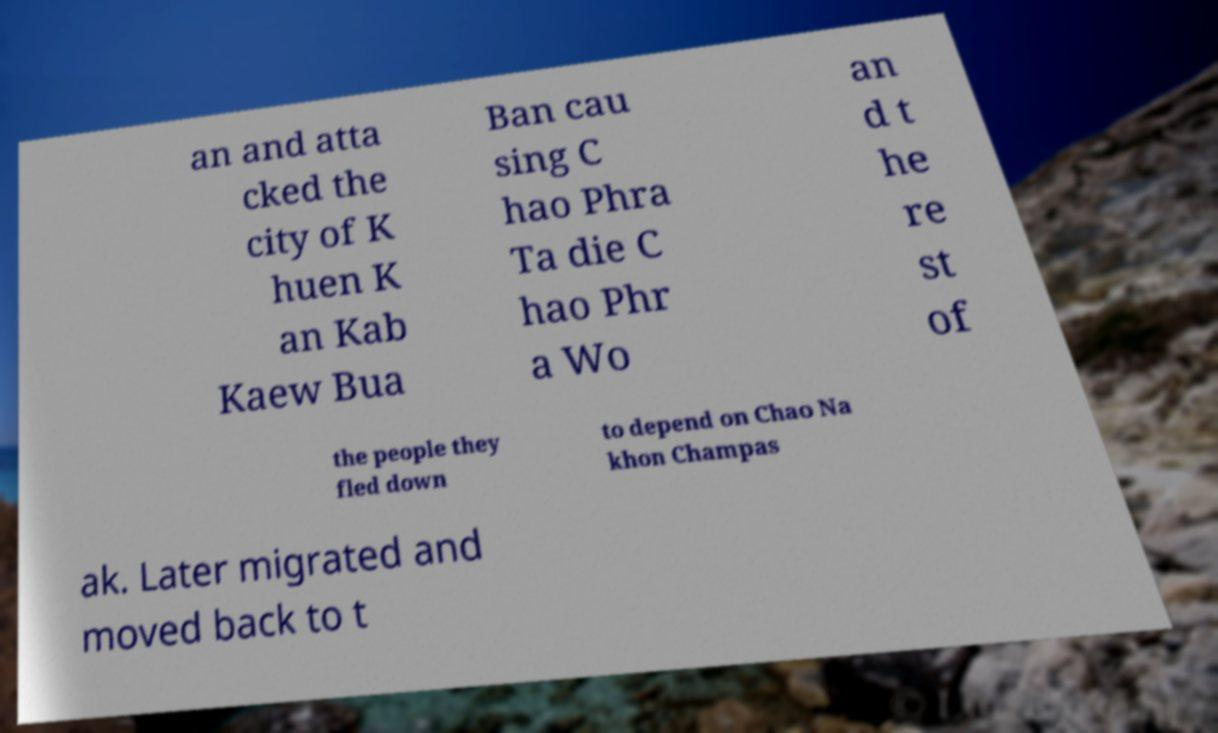For documentation purposes, I need the text within this image transcribed. Could you provide that? an and atta cked the city of K huen K an Kab Kaew Bua Ban cau sing C hao Phra Ta die C hao Phr a Wo an d t he re st of the people they fled down to depend on Chao Na khon Champas ak. Later migrated and moved back to t 